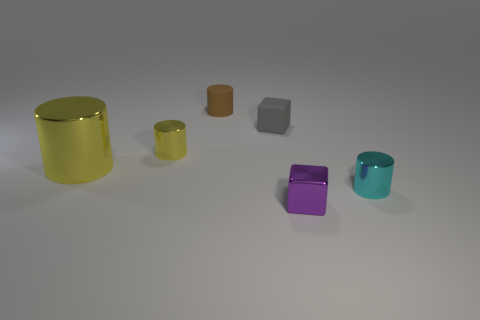How many objects are there in total? There are a total of six objects visible in the image. 